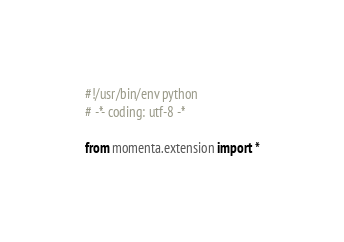Convert code to text. <code><loc_0><loc_0><loc_500><loc_500><_Python_>#!/usr/bin/env python
# -*- coding: utf-8 -*

from momenta.extension import *</code> 